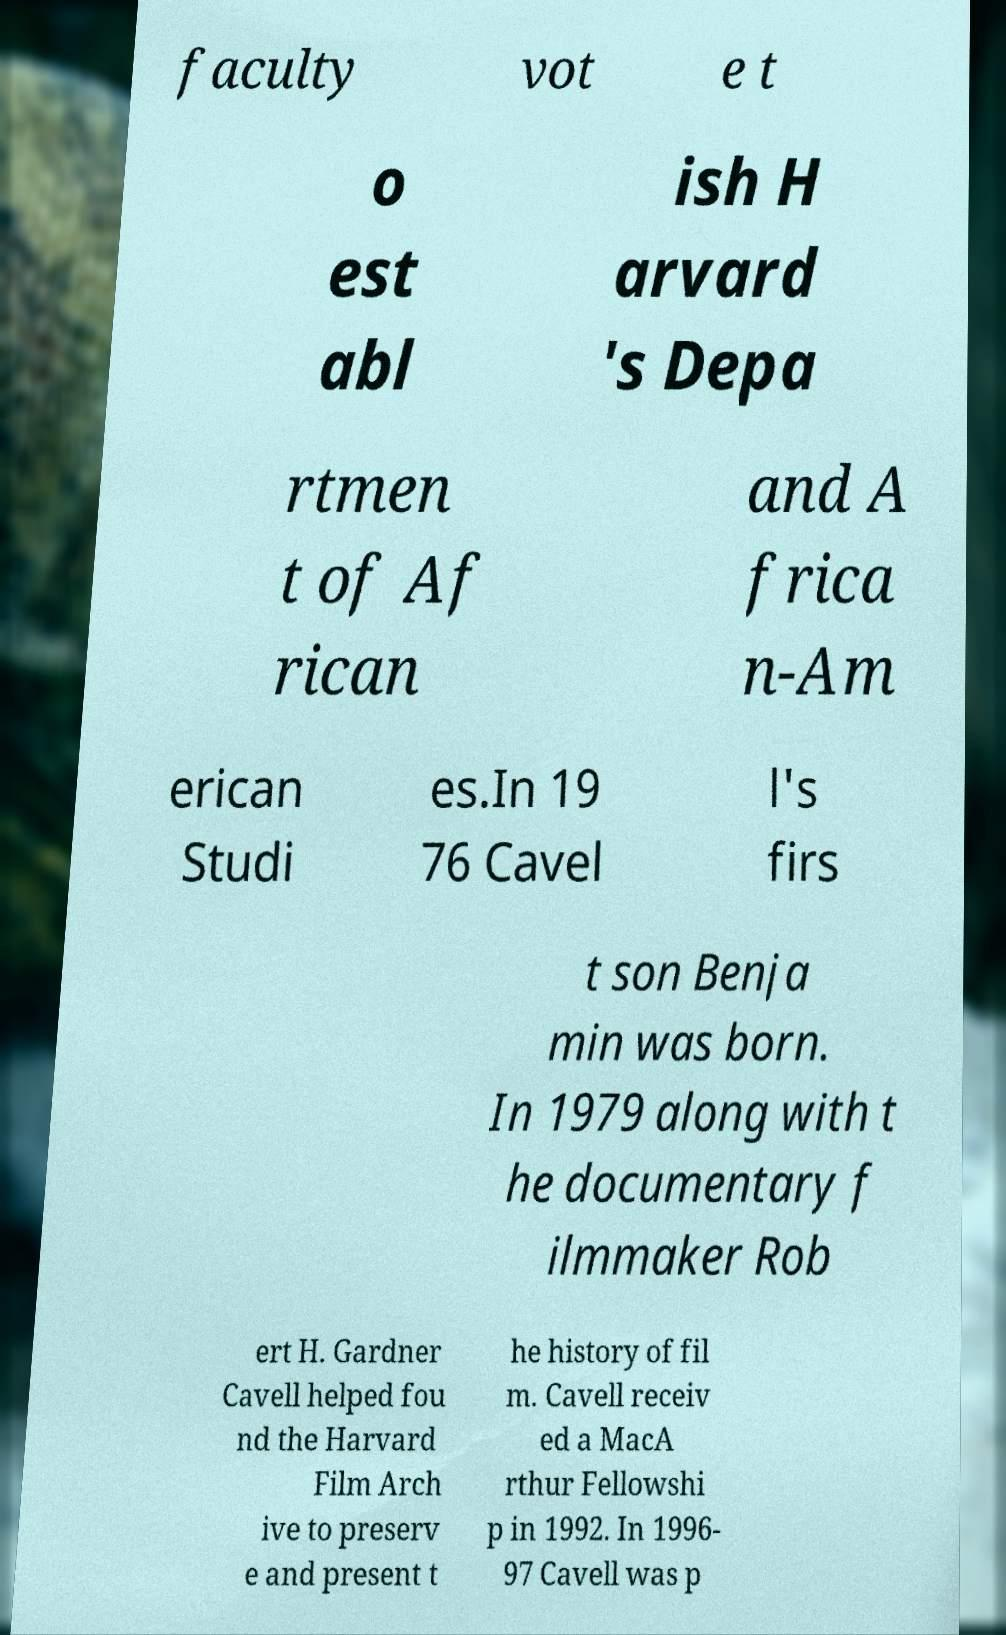Can you read and provide the text displayed in the image?This photo seems to have some interesting text. Can you extract and type it out for me? faculty vot e t o est abl ish H arvard 's Depa rtmen t of Af rican and A frica n-Am erican Studi es.In 19 76 Cavel l's firs t son Benja min was born. In 1979 along with t he documentary f ilmmaker Rob ert H. Gardner Cavell helped fou nd the Harvard Film Arch ive to preserv e and present t he history of fil m. Cavell receiv ed a MacA rthur Fellowshi p in 1992. In 1996- 97 Cavell was p 